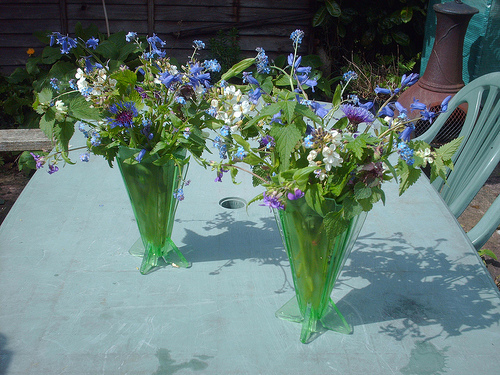Please provide a short description for this region: [0.54, 0.5, 0.74, 0.81]. A vase of a soft green hue, filled with an assortment of fresh flowers in various shades of blue and white, dominates this focal area of the image. 